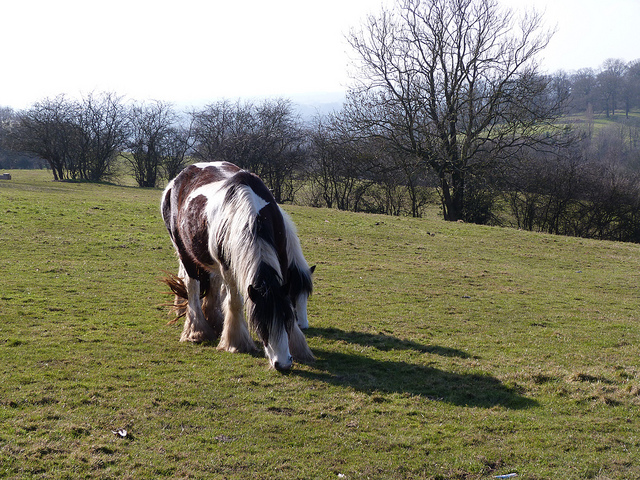Is the horse facing uphill or downhill? The horse is facing downhill, as indicated by the slope of the ground. 